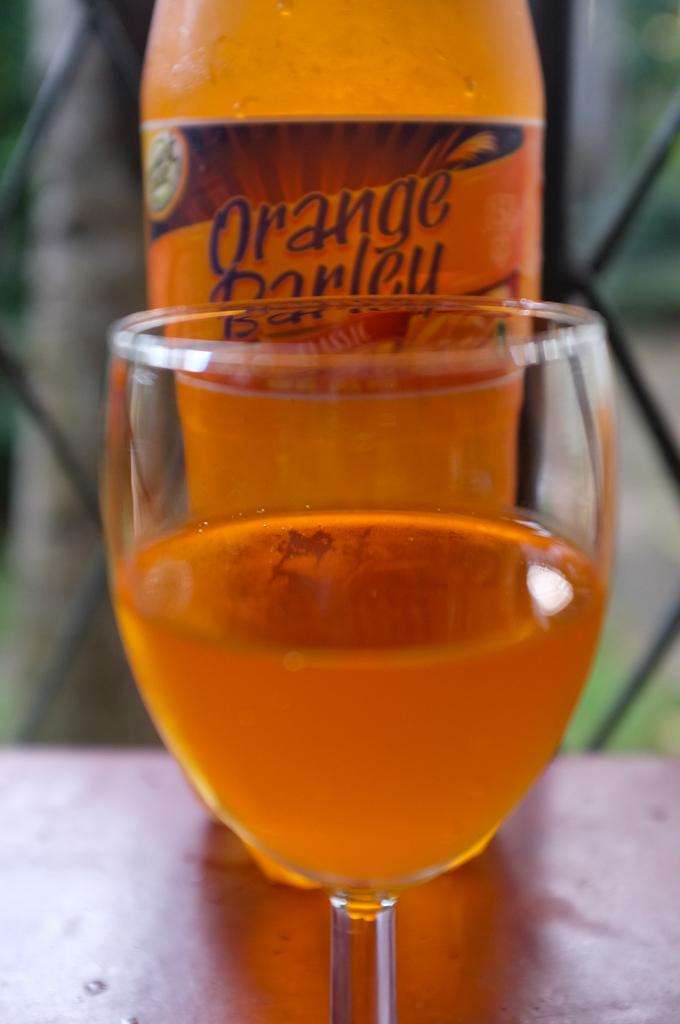What drink is in the bottle?
Provide a short and direct response. Orange barley. 